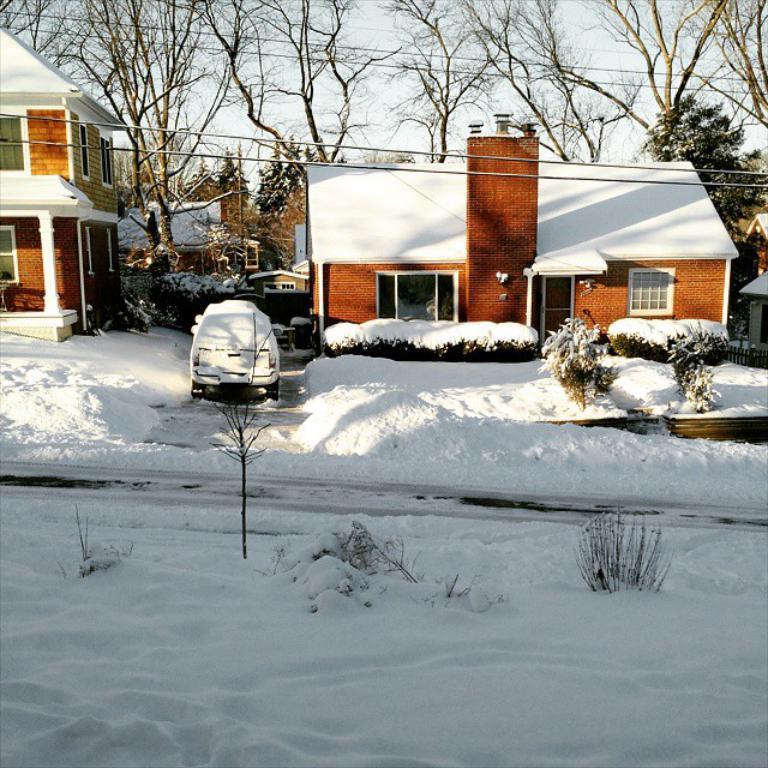Please provide a concise description of this image. At the center of the image we can see there are some buildings and trees. In front of the building there is a vehicle covered with snow. In the background there is a sky. 